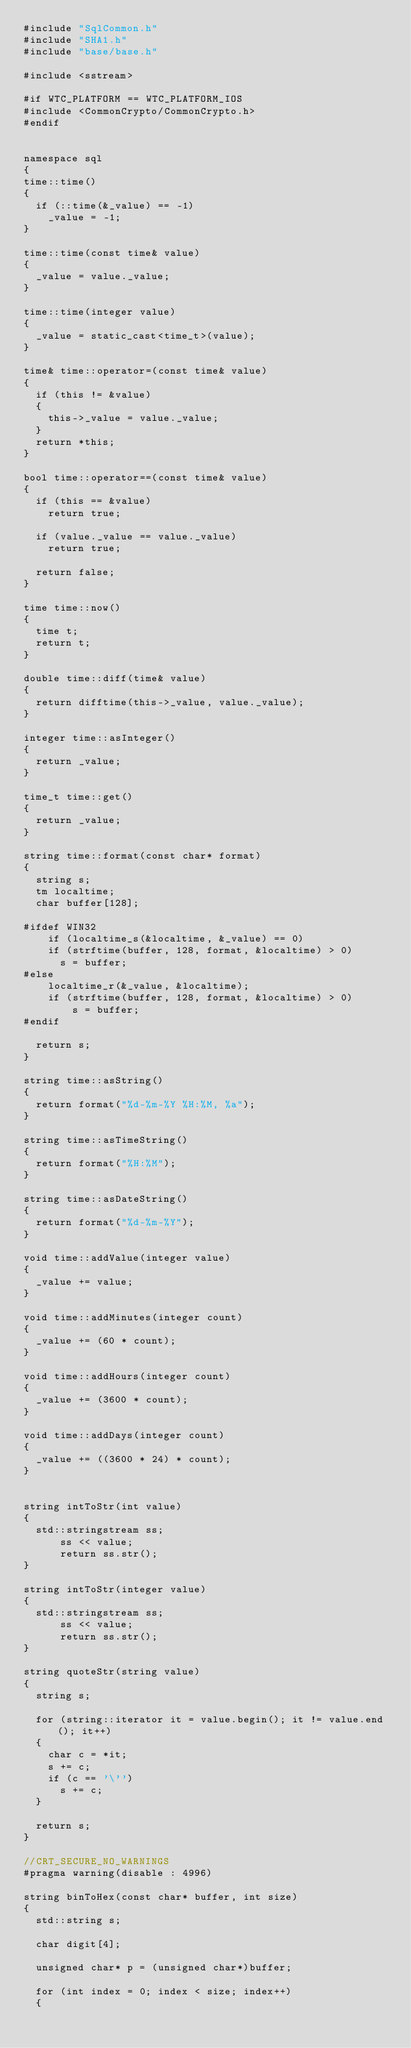Convert code to text. <code><loc_0><loc_0><loc_500><loc_500><_C++_>#include "SqlCommon.h"
#include "SHA1.h"
#include "base/base.h"

#include <sstream>

#if WTC_PLATFORM == WTC_PLATFORM_IOS
#include <CommonCrypto/CommonCrypto.h>
#endif


namespace sql
{
time::time()
{
	if (::time(&_value) == -1)
		_value = -1;
}

time::time(const time& value)
{
	_value = value._value;
}

time::time(integer value)
{
	_value = static_cast<time_t>(value);
}

time& time::operator=(const time& value)
{
	if (this != &value)
	{
		this->_value = value._value;
	}
	return *this;
}

bool time::operator==(const time& value)
{
	if (this == &value)
		return true;

	if (value._value == value._value)
		return true;

	return false;
}

time time::now()
{
	time t;
	return t;
}

double time::diff(time& value)
{
	return difftime(this->_value, value._value);
}

integer time::asInteger()
{
	return _value;
}

time_t time::get()
{
	return _value;
}

string time::format(const char* format)
{
	string s;
	tm localtime;
	char buffer[128];

#ifdef WIN32
    if (localtime_s(&localtime, &_value) == 0)
    if (strftime(buffer, 128, format, &localtime) > 0)
      s = buffer;
#else
    localtime_r(&_value, &localtime);
    if (strftime(buffer, 128, format, &localtime) > 0)
        s = buffer;
#endif

	return s;
}

string time::asString()
{
	return format("%d-%m-%Y %H:%M, %a");
}

string time::asTimeString()
{
	return format("%H:%M");
}

string time::asDateString()
{
	return format("%d-%m-%Y");
}

void time::addValue(integer value)
{
	_value += value;
}

void time::addMinutes(integer count)
{
	_value += (60 * count);
}

void time::addHours(integer count)
{
	_value += (3600 * count);
}

void time::addDays(integer count)
{
	_value += ((3600 * 24) * count);
}


string intToStr(int value)
{
  std::stringstream ss;
      ss << value;
      return ss.str();
}

string intToStr(integer value)
{
  std::stringstream ss;
      ss << value;
      return ss.str();
}

string quoteStr(string value)
{
	string s;

	for (string::iterator it = value.begin(); it != value.end(); it++)
	{
		char c = *it;
		s += c;
		if (c == '\'')
			s += c;
	}

	return s;
}

//CRT_SECURE_NO_WARNINGS
#pragma warning(disable : 4996)

string binToHex(const char* buffer, int size)
{
	std::string s;

	char digit[4];

	unsigned char* p = (unsigned char*)buffer;

	for (int index = 0; index < size; index++)
	{</code> 